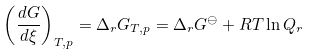Convert formula to latex. <formula><loc_0><loc_0><loc_500><loc_500>\left ( { \frac { d G } { d \xi } } \right ) _ { T , p } = \Delta _ { r } G _ { T , p } = \Delta _ { r } G ^ { \ominus } + R T \ln Q _ { r }</formula> 